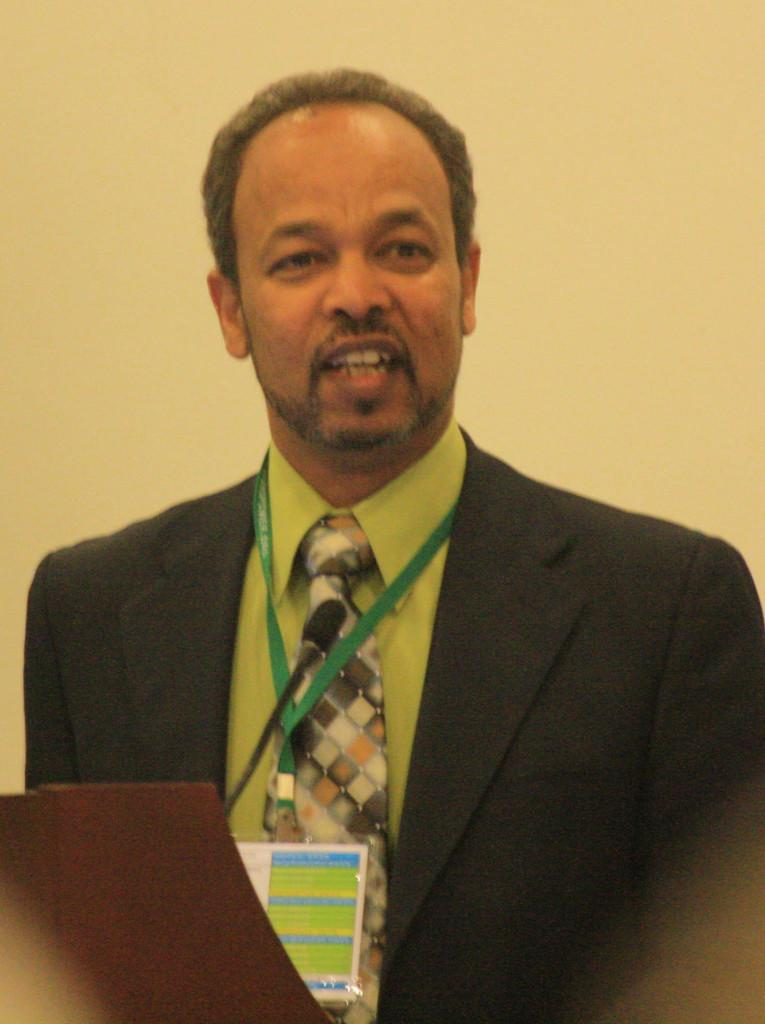What is the main subject of the image? The main subject of the image is a man standing. What object is placed in front of the man? There is a microphone placed in front of the man. What type of gold object is visible in the image? There is no gold object present in the image. What type of glass object is visible in the image? There is no glass object present in the image. 